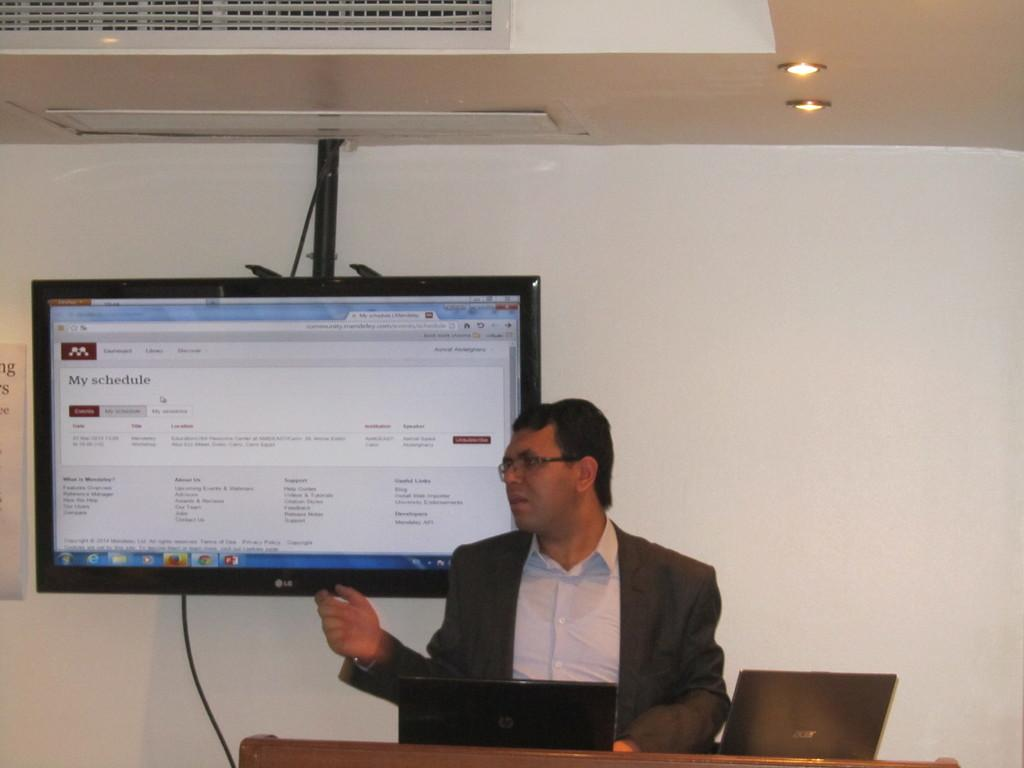Provide a one-sentence caption for the provided image. a man with his schedule on a television behind him. 